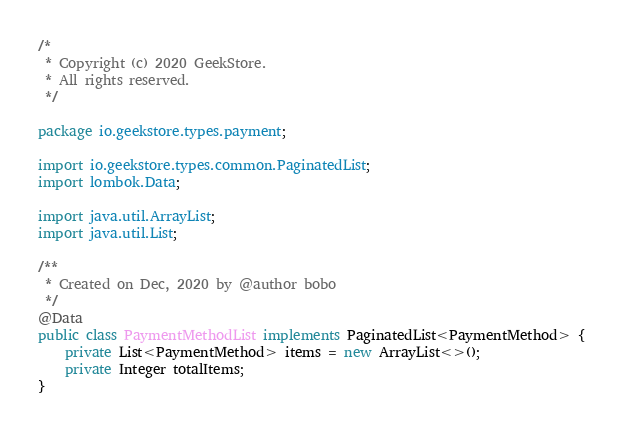Convert code to text. <code><loc_0><loc_0><loc_500><loc_500><_Java_>/*
 * Copyright (c) 2020 GeekStore.
 * All rights reserved.
 */

package io.geekstore.types.payment;

import io.geekstore.types.common.PaginatedList;
import lombok.Data;

import java.util.ArrayList;
import java.util.List;

/**
 * Created on Dec, 2020 by @author bobo
 */
@Data
public class PaymentMethodList implements PaginatedList<PaymentMethod> {
    private List<PaymentMethod> items = new ArrayList<>();
    private Integer totalItems;
}
</code> 